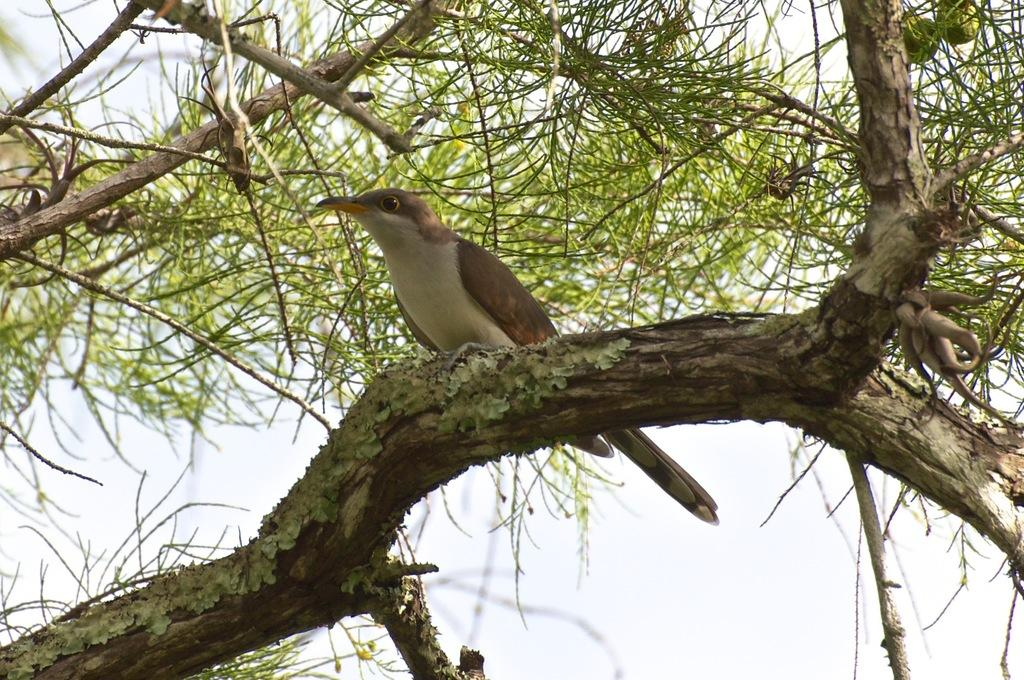What is the main object in the image? There is a tree in the image. Is there any wildlife present on the tree? Yes, there is a bird on the tree. What can be seen in the background of the image? The sky is visible in the background of the image. What type of protest is happening in the image? There is no protest present in the image; it features a tree with a bird on it and a visible sky in the background. 